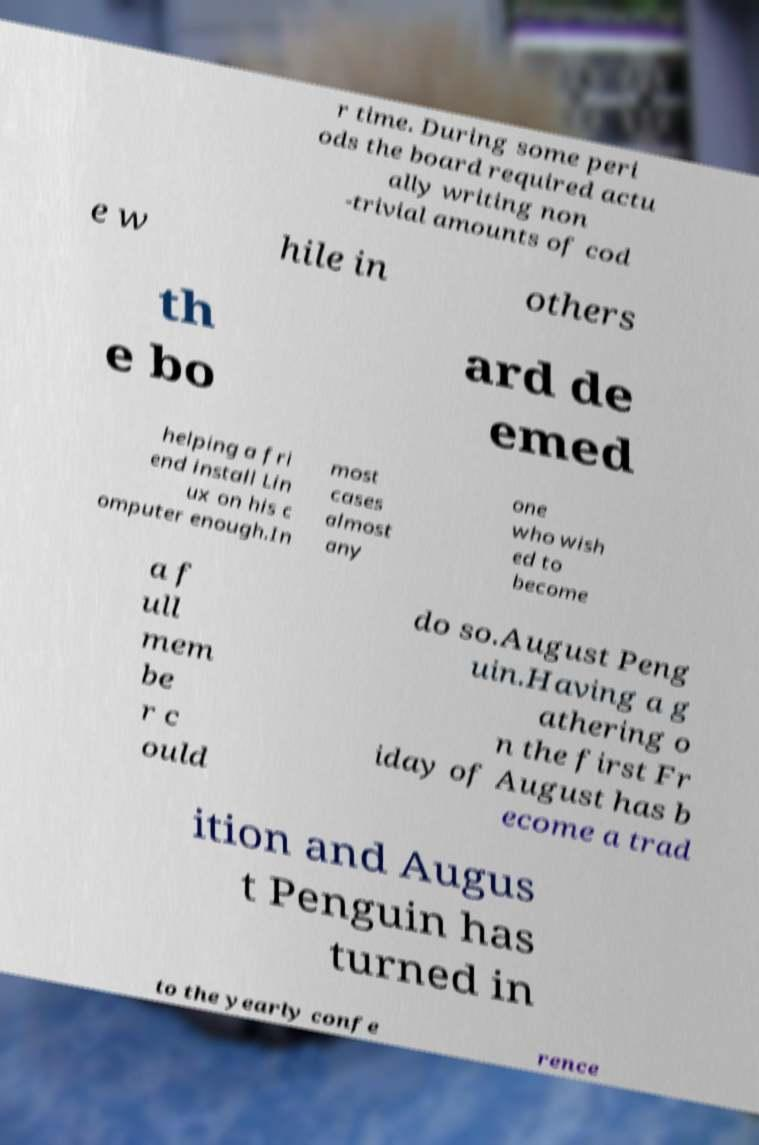I need the written content from this picture converted into text. Can you do that? r time. During some peri ods the board required actu ally writing non -trivial amounts of cod e w hile in others th e bo ard de emed helping a fri end install Lin ux on his c omputer enough.In most cases almost any one who wish ed to become a f ull mem be r c ould do so.August Peng uin.Having a g athering o n the first Fr iday of August has b ecome a trad ition and Augus t Penguin has turned in to the yearly confe rence 